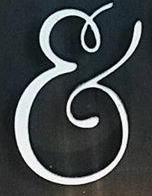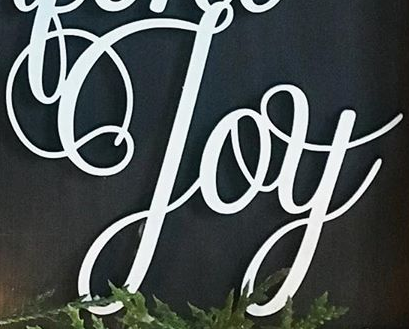What words can you see in these images in sequence, separated by a semicolon? &; Joy 